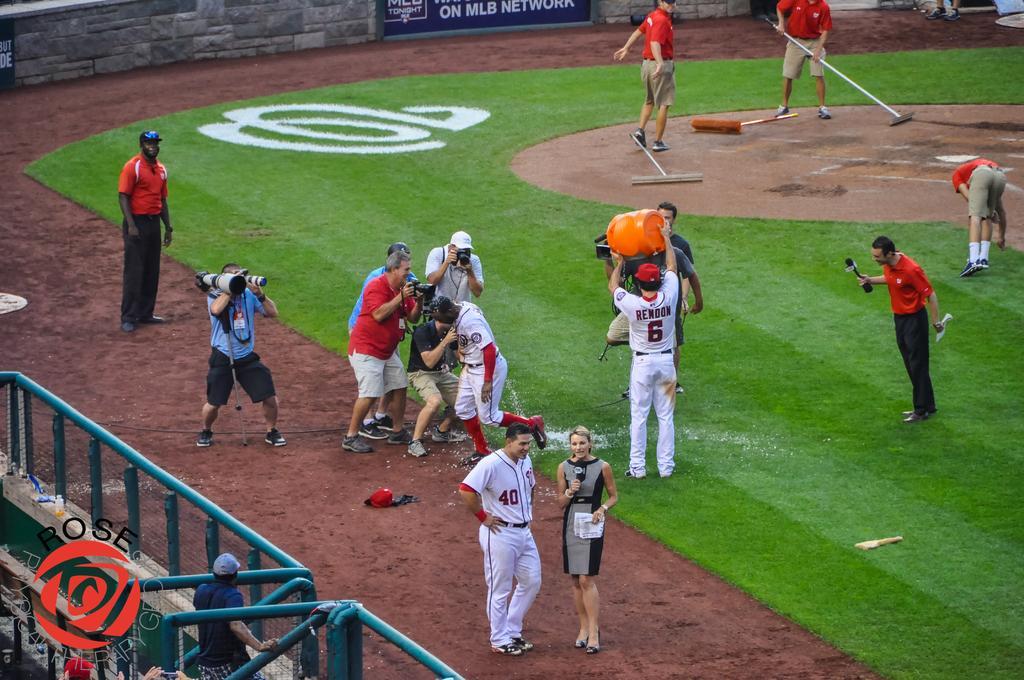Describe this image in one or two sentences. In this image I see number of people in which these 3 of them are holding cameras and these 2 persons are holding mics and I see the ground on which there is green grass and I see white lines over her and I see the fencing over here and I see boards on which there are words written and I see this man is holding a thing in his hand and I see the similar things over here. 